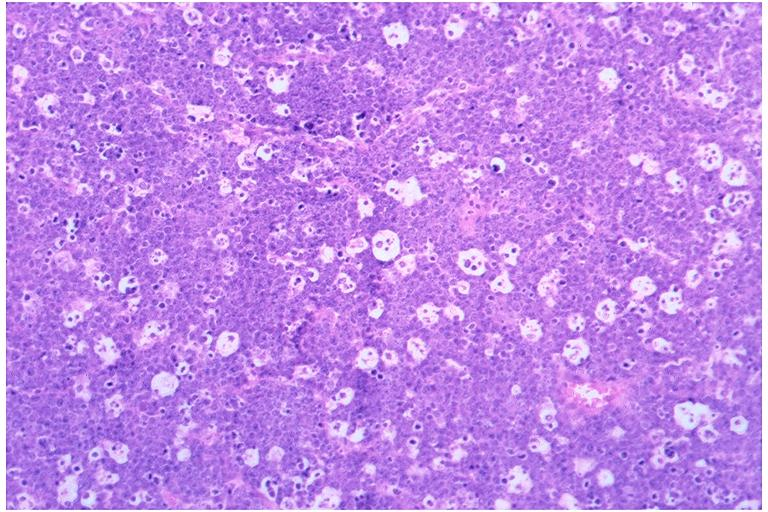does this image show burkits lymphoma?
Answer the question using a single word or phrase. Yes 